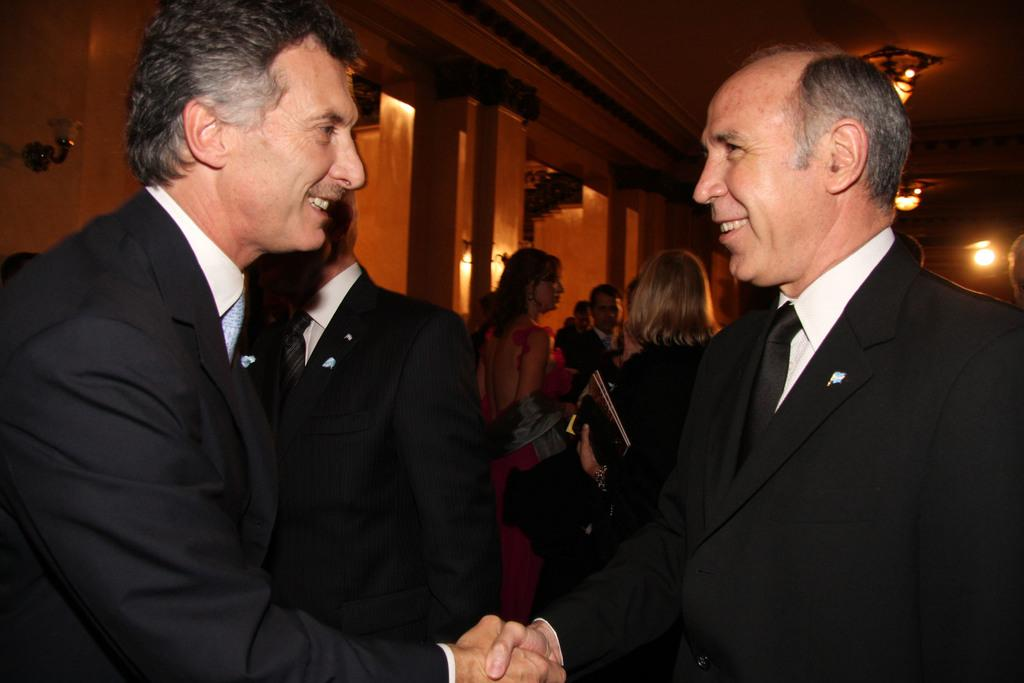What is happening in the image? There is a group of people standing in the image. Can you describe what one woman is holding in her hand? One woman is holding books and some objects in her hand. What can be seen in the background of the image? There are group of lights and pillars in the background of the image. What type of waste can be seen in the field in the image? There is no field or waste present in the image. What is the woman doing with her hand in the image? The woman is holding books and some objects in her hand, as described earlier. 